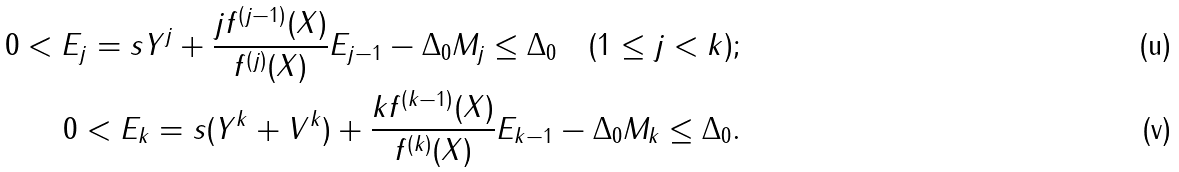Convert formula to latex. <formula><loc_0><loc_0><loc_500><loc_500>0 < E _ { j } = s Y ^ { j } + \frac { j f ^ { ( j - 1 ) } ( X ) } { f ^ { ( j ) } ( X ) } E _ { j - 1 } - \Delta _ { 0 } M _ { j } \leq \Delta _ { 0 } \quad ( 1 \leq j < k ) ; \\ 0 < E _ { k } = s ( Y ^ { k } + V ^ { k } ) + \frac { k f ^ { ( k - 1 ) } ( X ) } { f ^ { ( k ) } ( X ) } E _ { k - 1 } - \Delta _ { 0 } M _ { k } \leq \Delta _ { 0 } .</formula> 